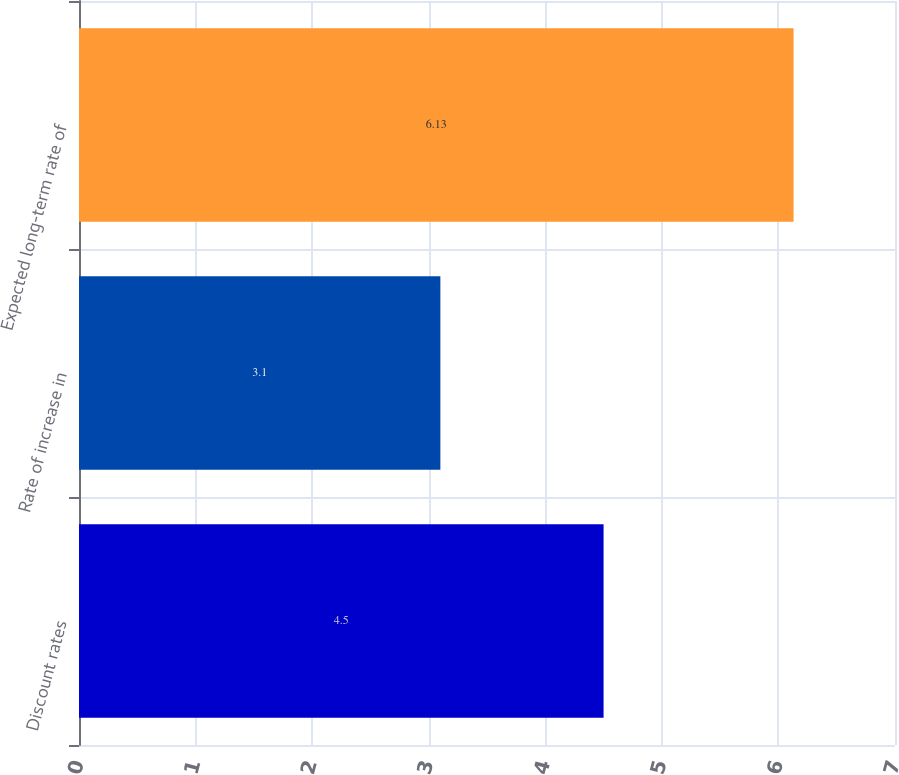Convert chart. <chart><loc_0><loc_0><loc_500><loc_500><bar_chart><fcel>Discount rates<fcel>Rate of increase in<fcel>Expected long-term rate of<nl><fcel>4.5<fcel>3.1<fcel>6.13<nl></chart> 